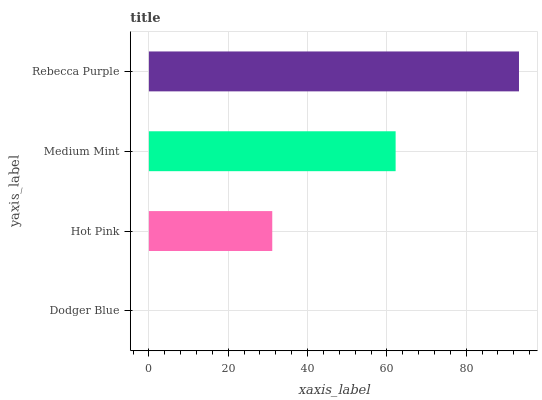Is Dodger Blue the minimum?
Answer yes or no. Yes. Is Rebecca Purple the maximum?
Answer yes or no. Yes. Is Hot Pink the minimum?
Answer yes or no. No. Is Hot Pink the maximum?
Answer yes or no. No. Is Hot Pink greater than Dodger Blue?
Answer yes or no. Yes. Is Dodger Blue less than Hot Pink?
Answer yes or no. Yes. Is Dodger Blue greater than Hot Pink?
Answer yes or no. No. Is Hot Pink less than Dodger Blue?
Answer yes or no. No. Is Medium Mint the high median?
Answer yes or no. Yes. Is Hot Pink the low median?
Answer yes or no. Yes. Is Dodger Blue the high median?
Answer yes or no. No. Is Dodger Blue the low median?
Answer yes or no. No. 